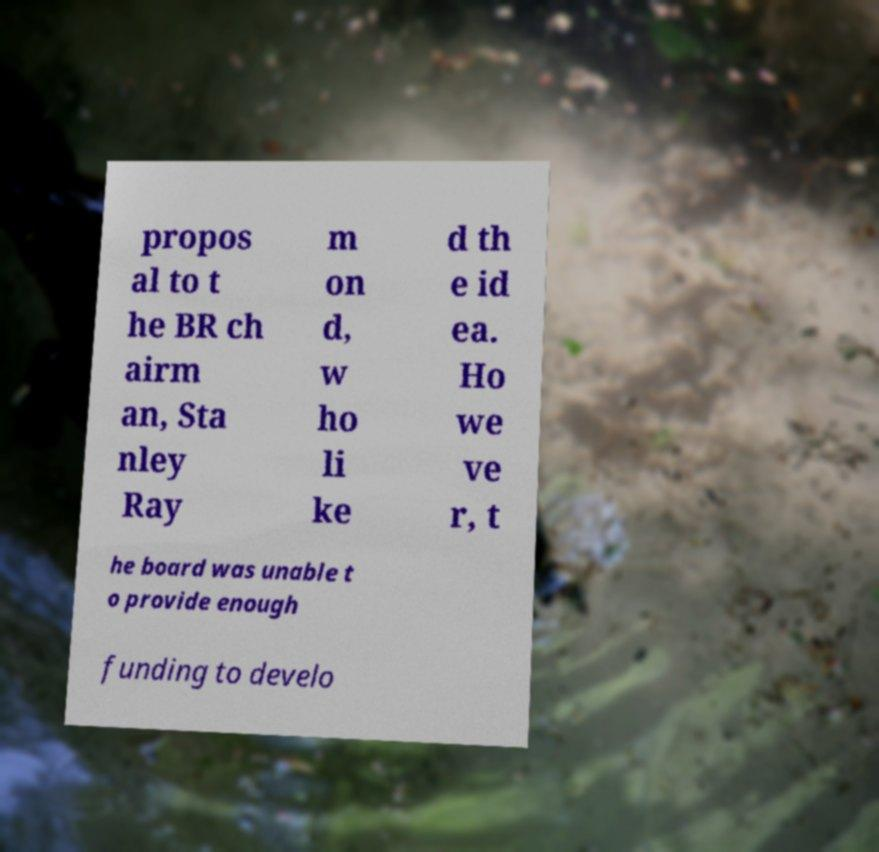Please read and relay the text visible in this image. What does it say? propos al to t he BR ch airm an, Sta nley Ray m on d, w ho li ke d th e id ea. Ho we ve r, t he board was unable t o provide enough funding to develo 